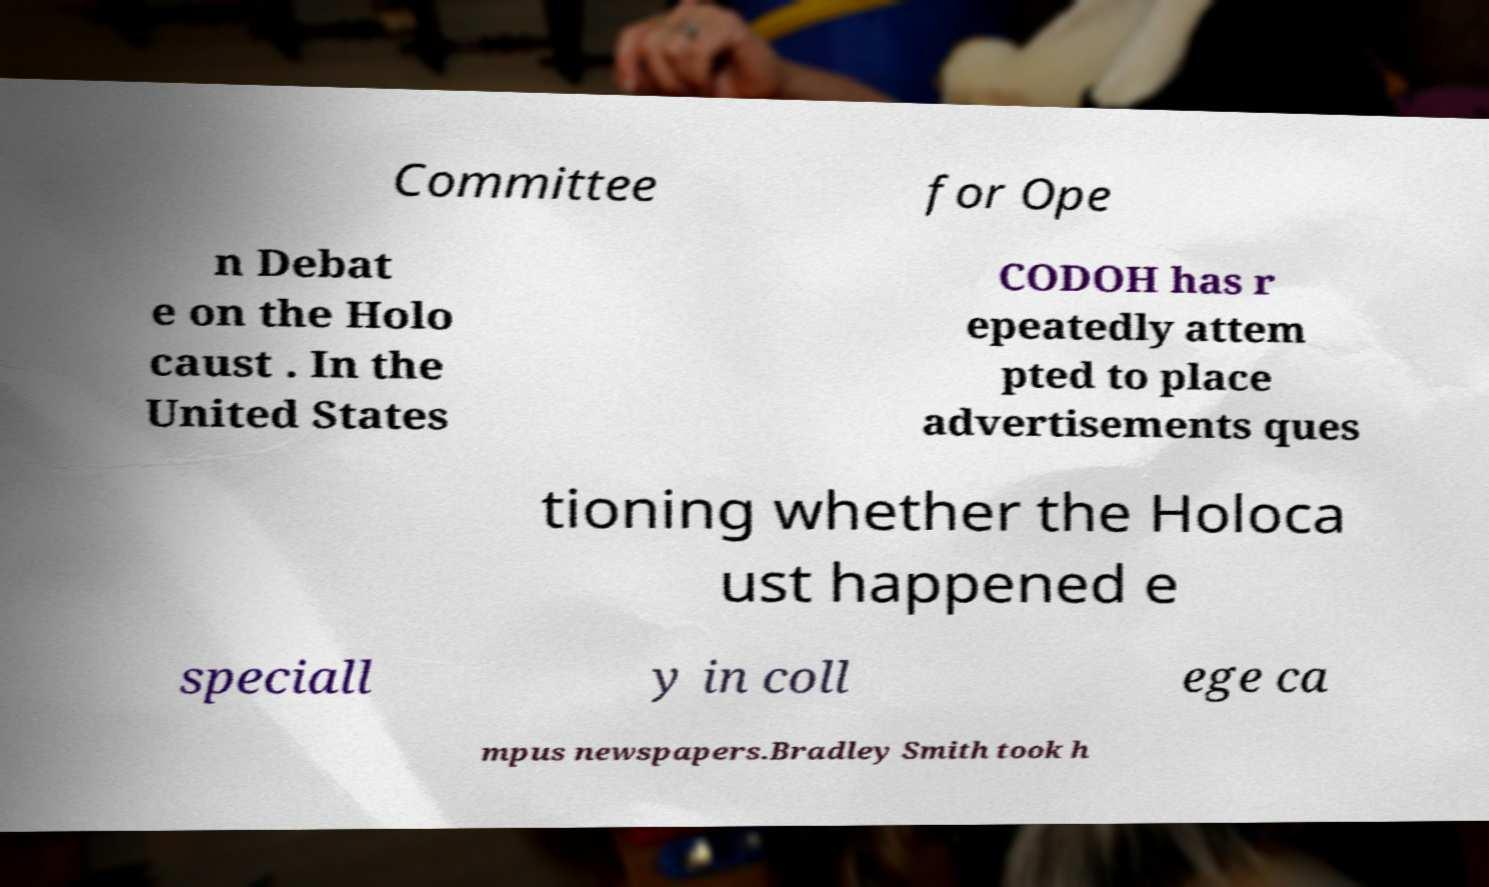Can you read and provide the text displayed in the image?This photo seems to have some interesting text. Can you extract and type it out for me? Committee for Ope n Debat e on the Holo caust . In the United States CODOH has r epeatedly attem pted to place advertisements ques tioning whether the Holoca ust happened e speciall y in coll ege ca mpus newspapers.Bradley Smith took h 